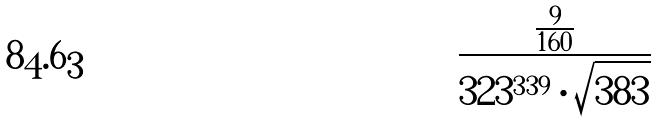<formula> <loc_0><loc_0><loc_500><loc_500>\frac { \frac { 9 } { 1 6 0 } } { 3 2 3 ^ { 3 3 9 } \cdot \sqrt { 3 8 3 } }</formula> 